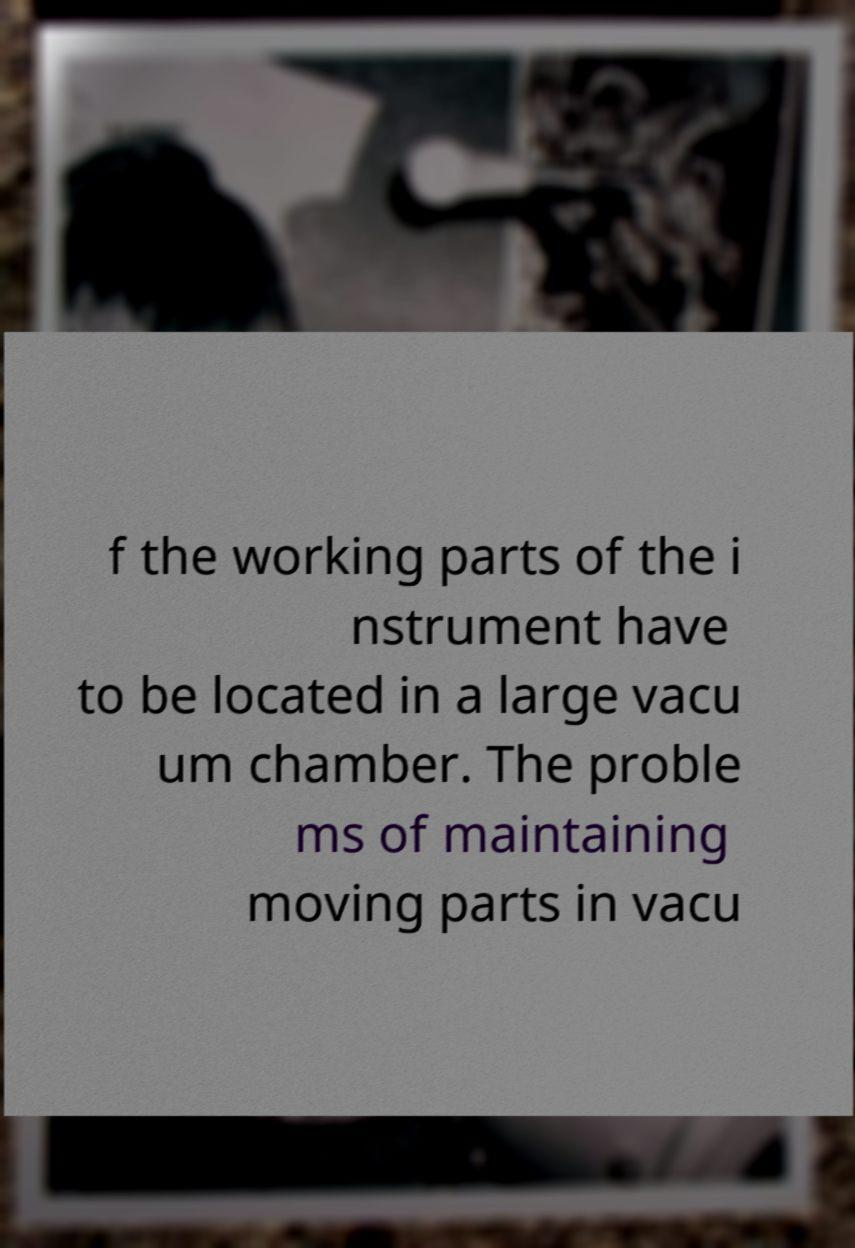Please read and relay the text visible in this image. What does it say? f the working parts of the i nstrument have to be located in a large vacu um chamber. The proble ms of maintaining moving parts in vacu 